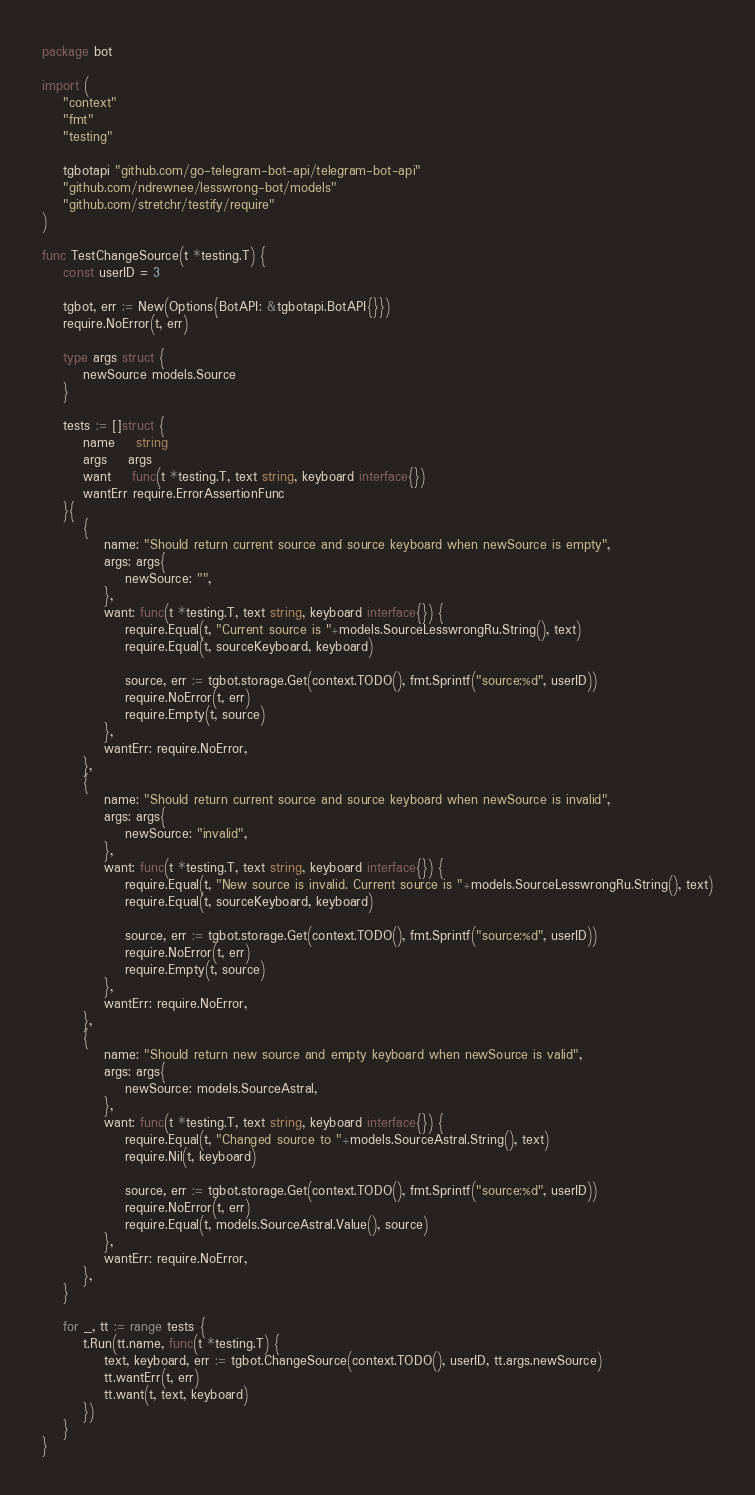Convert code to text. <code><loc_0><loc_0><loc_500><loc_500><_Go_>package bot

import (
	"context"
	"fmt"
	"testing"

	tgbotapi "github.com/go-telegram-bot-api/telegram-bot-api"
	"github.com/ndrewnee/lesswrong-bot/models"
	"github.com/stretchr/testify/require"
)

func TestChangeSource(t *testing.T) {
	const userID = 3

	tgbot, err := New(Options{BotAPI: &tgbotapi.BotAPI{}})
	require.NoError(t, err)

	type args struct {
		newSource models.Source
	}

	tests := []struct {
		name    string
		args    args
		want    func(t *testing.T, text string, keyboard interface{})
		wantErr require.ErrorAssertionFunc
	}{
		{
			name: "Should return current source and source keyboard when newSource is empty",
			args: args{
				newSource: "",
			},
			want: func(t *testing.T, text string, keyboard interface{}) {
				require.Equal(t, "Current source is "+models.SourceLesswrongRu.String(), text)
				require.Equal(t, sourceKeyboard, keyboard)

				source, err := tgbot.storage.Get(context.TODO(), fmt.Sprintf("source:%d", userID))
				require.NoError(t, err)
				require.Empty(t, source)
			},
			wantErr: require.NoError,
		},
		{
			name: "Should return current source and source keyboard when newSource is invalid",
			args: args{
				newSource: "invalid",
			},
			want: func(t *testing.T, text string, keyboard interface{}) {
				require.Equal(t, "New source is invalid. Current source is "+models.SourceLesswrongRu.String(), text)
				require.Equal(t, sourceKeyboard, keyboard)

				source, err := tgbot.storage.Get(context.TODO(), fmt.Sprintf("source:%d", userID))
				require.NoError(t, err)
				require.Empty(t, source)
			},
			wantErr: require.NoError,
		},
		{
			name: "Should return new source and empty keyboard when newSource is valid",
			args: args{
				newSource: models.SourceAstral,
			},
			want: func(t *testing.T, text string, keyboard interface{}) {
				require.Equal(t, "Changed source to "+models.SourceAstral.String(), text)
				require.Nil(t, keyboard)

				source, err := tgbot.storage.Get(context.TODO(), fmt.Sprintf("source:%d", userID))
				require.NoError(t, err)
				require.Equal(t, models.SourceAstral.Value(), source)
			},
			wantErr: require.NoError,
		},
	}

	for _, tt := range tests {
		t.Run(tt.name, func(t *testing.T) {
			text, keyboard, err := tgbot.ChangeSource(context.TODO(), userID, tt.args.newSource)
			tt.wantErr(t, err)
			tt.want(t, text, keyboard)
		})
	}
}
</code> 